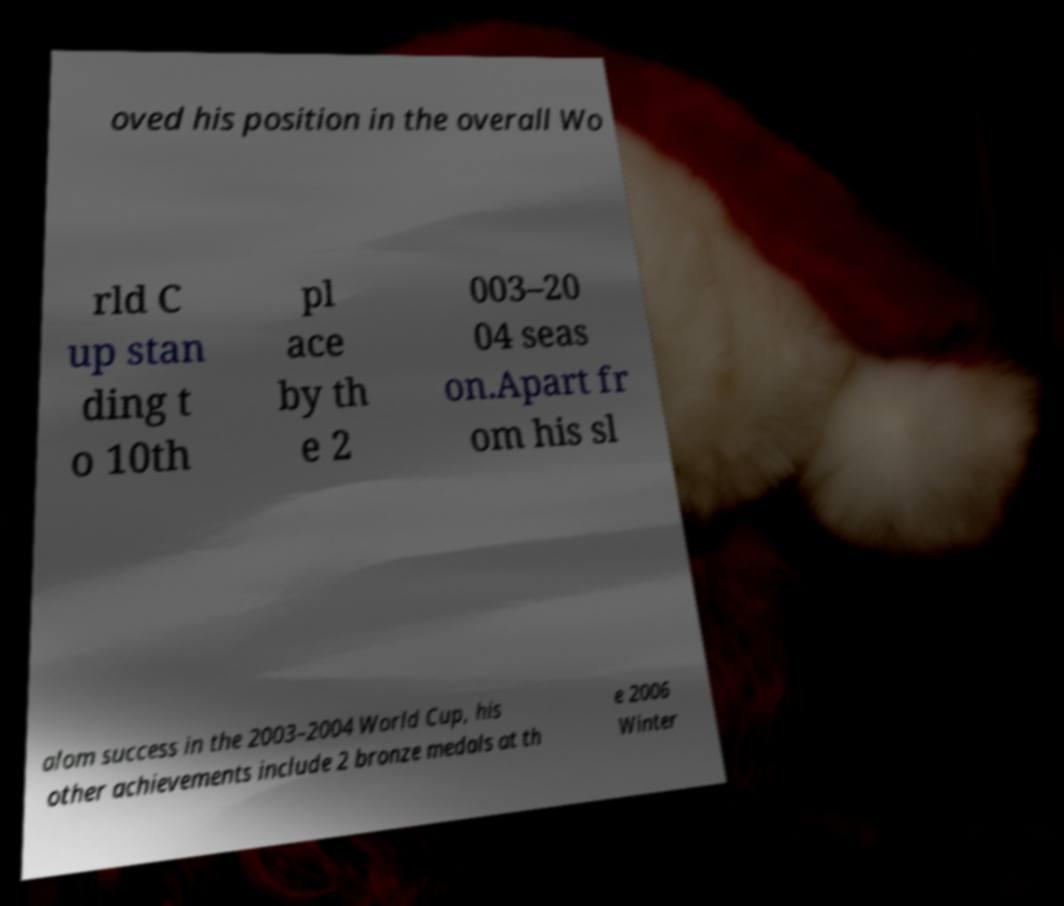I need the written content from this picture converted into text. Can you do that? oved his position in the overall Wo rld C up stan ding t o 10th pl ace by th e 2 003–20 04 seas on.Apart fr om his sl alom success in the 2003–2004 World Cup, his other achievements include 2 bronze medals at th e 2006 Winter 